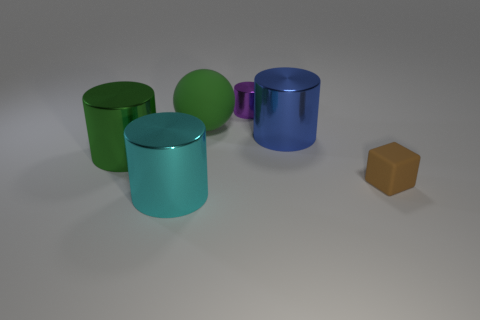Are the objects arranged in any specific pattern? The objects in the image appear to be arranged casually rather than following a strict pattern. They are spaced out unevenly across the plane, with no apparent alignment or symmetry. The varied colors and sizes of the shapes contribute to the sense of an arbitrary arrangement. Does the arrangement tell us anything about the context in which the image might have been taken? The random positioning of the shapes might suggest that the image is a setup for a visual or spatial cognition experiment, an artistic composition, or a rendering designed to showcase the objects' colors and reflections. The controlled environment, with its neutral background and lighting that causes reflections, serves to highlight the objects without providing much additional context. 